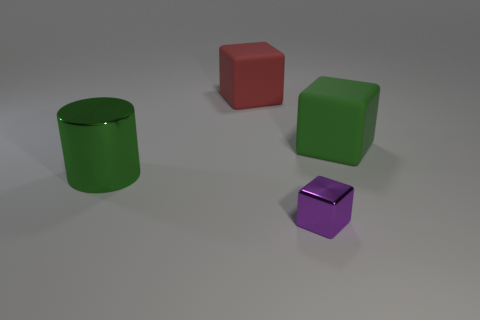Add 1 red cubes. How many objects exist? 5 Subtract all cubes. How many objects are left? 1 Add 4 large green matte blocks. How many large green matte blocks exist? 5 Subtract 0 yellow spheres. How many objects are left? 4 Subtract all big cyan cubes. Subtract all big blocks. How many objects are left? 2 Add 4 large rubber objects. How many large rubber objects are left? 6 